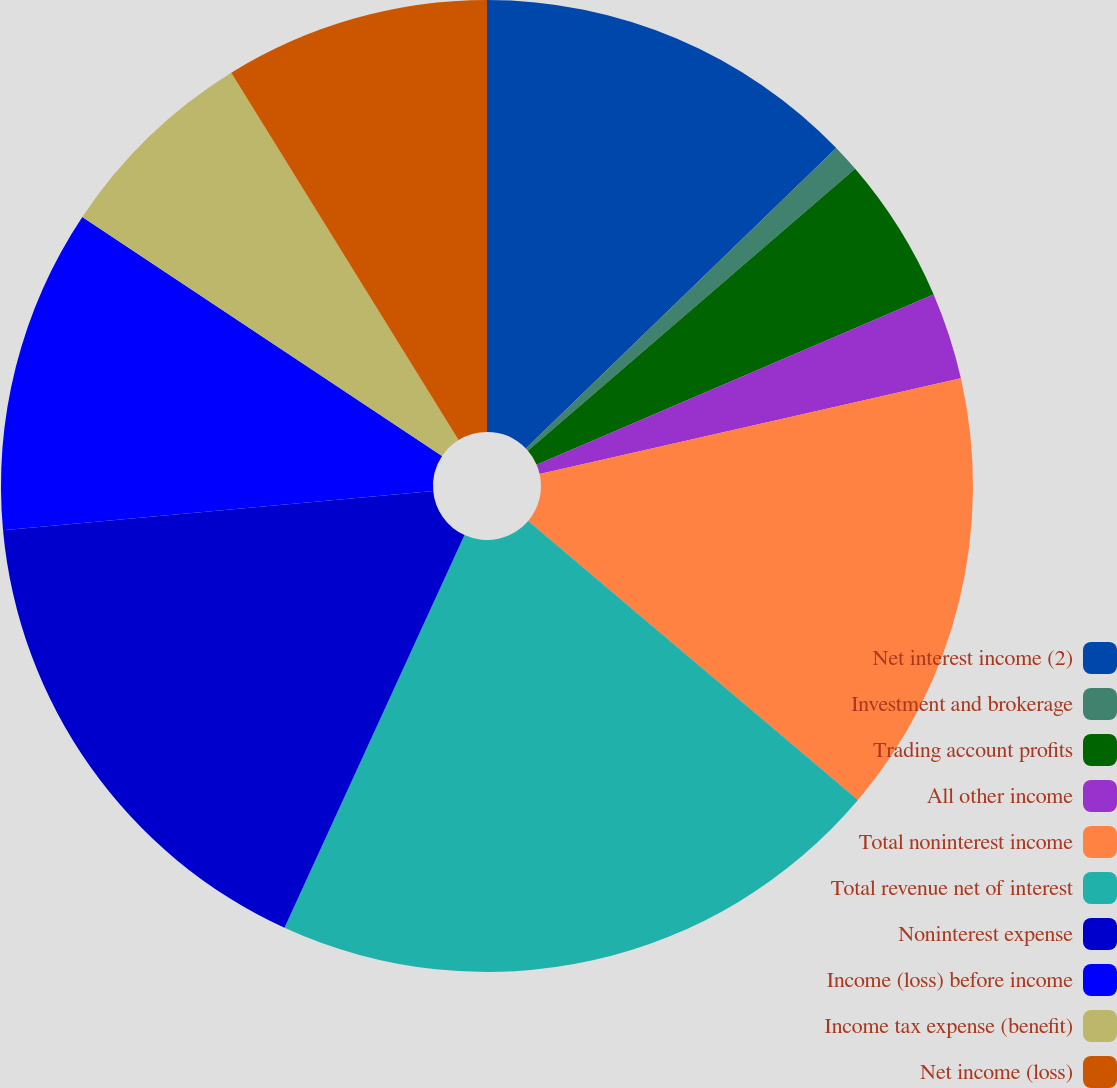<chart> <loc_0><loc_0><loc_500><loc_500><pie_chart><fcel>Net interest income (2)<fcel>Investment and brokerage<fcel>Trading account profits<fcel>All other income<fcel>Total noninterest income<fcel>Total revenue net of interest<fcel>Noninterest expense<fcel>Income (loss) before income<fcel>Income tax expense (benefit)<fcel>Net income (loss)<nl><fcel>12.76%<fcel>0.92%<fcel>4.87%<fcel>2.89%<fcel>14.74%<fcel>20.66%<fcel>16.71%<fcel>10.79%<fcel>6.84%<fcel>8.82%<nl></chart> 